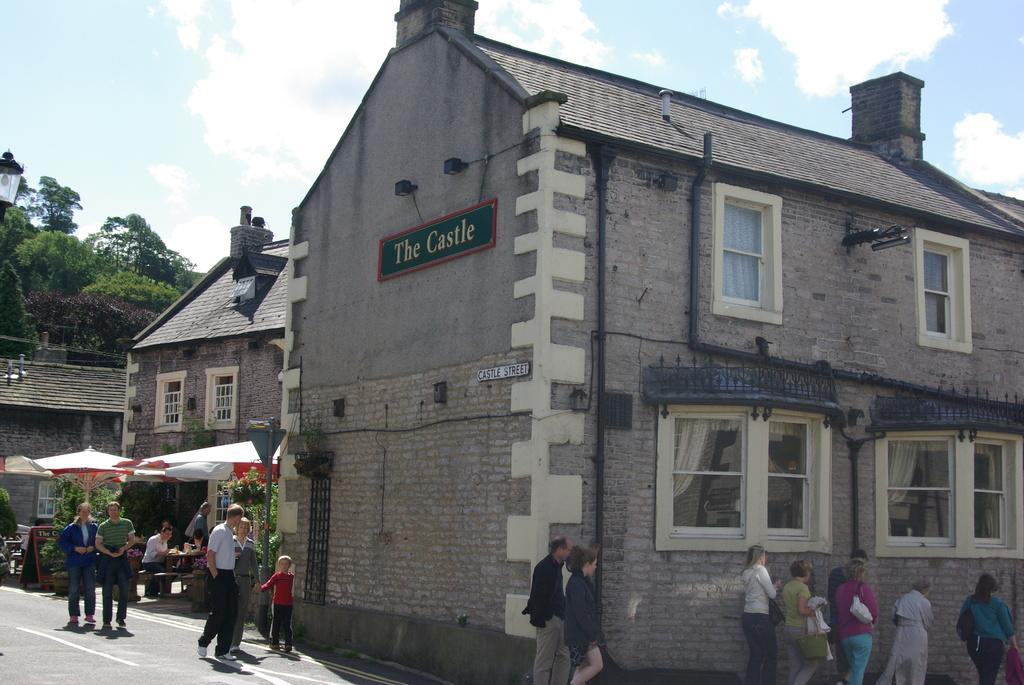What is located in the center of the image? There are buildings in the center of the image. What objects can be seen at the bottom of the image? Umbrellas, persons, and tables are visible at the bottom of the image. What is the surface at the bottom of the image? There is a road at the bottom of the image. What can be seen in the background of the image? Trees, the sky, and clouds are present in the background of the image. Can you tell me how many potatoes are being grown in the space depicted in the image? There are no potatoes or space-related activities present in the image. Is there a crook visible in the image? There is no crook present in the image. 